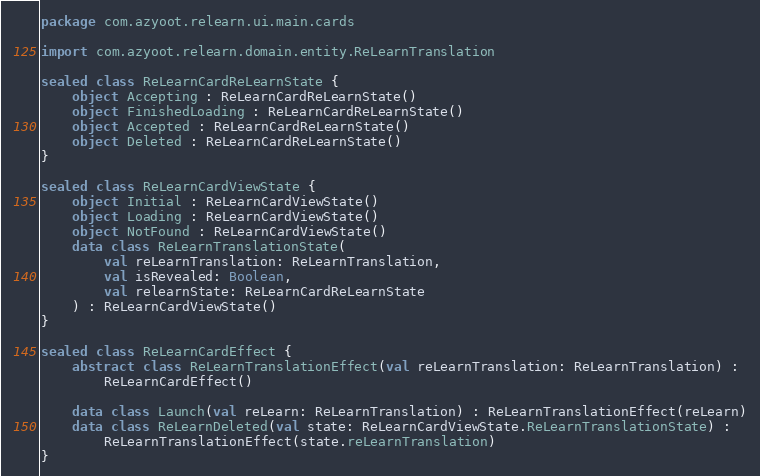Convert code to text. <code><loc_0><loc_0><loc_500><loc_500><_Kotlin_>package com.azyoot.relearn.ui.main.cards

import com.azyoot.relearn.domain.entity.ReLearnTranslation

sealed class ReLearnCardReLearnState {
    object Accepting : ReLearnCardReLearnState()
    object FinishedLoading : ReLearnCardReLearnState()
    object Accepted : ReLearnCardReLearnState()
    object Deleted : ReLearnCardReLearnState()
}

sealed class ReLearnCardViewState {
    object Initial : ReLearnCardViewState()
    object Loading : ReLearnCardViewState()
    object NotFound : ReLearnCardViewState()
    data class ReLearnTranslationState(
        val reLearnTranslation: ReLearnTranslation,
        val isRevealed: Boolean,
        val relearnState: ReLearnCardReLearnState
    ) : ReLearnCardViewState()
}

sealed class ReLearnCardEffect {
    abstract class ReLearnTranslationEffect(val reLearnTranslation: ReLearnTranslation) :
        ReLearnCardEffect()

    data class Launch(val reLearn: ReLearnTranslation) : ReLearnTranslationEffect(reLearn)
    data class ReLearnDeleted(val state: ReLearnCardViewState.ReLearnTranslationState) :
        ReLearnTranslationEffect(state.reLearnTranslation)
}</code> 